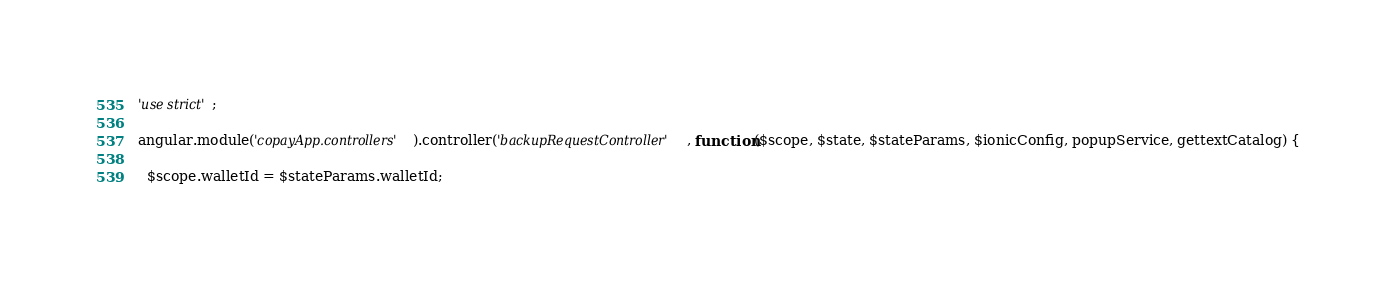<code> <loc_0><loc_0><loc_500><loc_500><_JavaScript_>'use strict';

angular.module('copayApp.controllers').controller('backupRequestController', function($scope, $state, $stateParams, $ionicConfig, popupService, gettextCatalog) {

  $scope.walletId = $stateParams.walletId;
</code> 